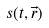Convert formula to latex. <formula><loc_0><loc_0><loc_500><loc_500>s ( t , \vec { r } )</formula> 